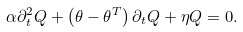Convert formula to latex. <formula><loc_0><loc_0><loc_500><loc_500>\alpha \partial _ { t } ^ { 2 } Q + \left ( \theta - \theta ^ { T } \right ) \partial _ { t } Q + \eta Q = 0 .</formula> 